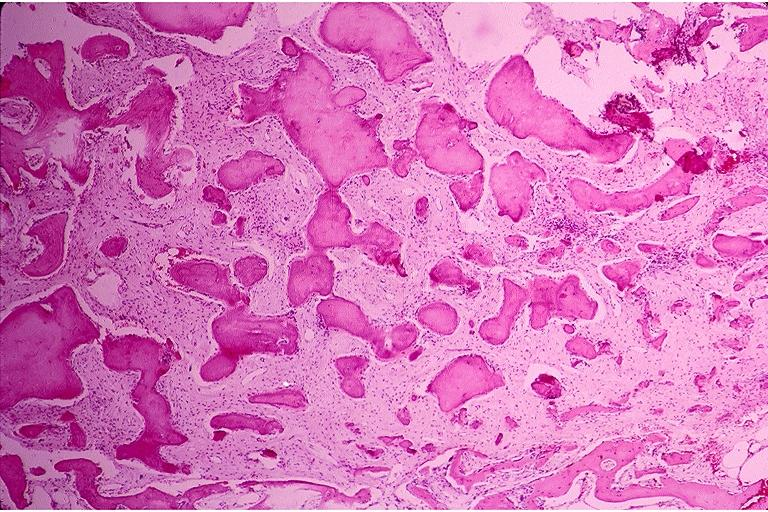s beckwith-wiedemann syndrome present?
Answer the question using a single word or phrase. No 